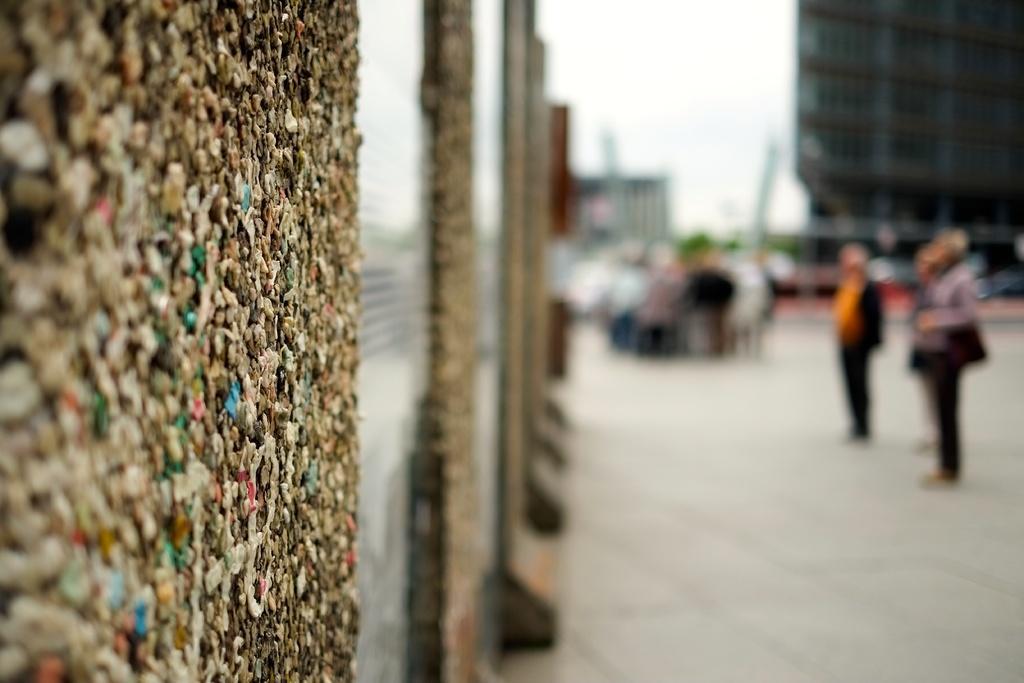In one or two sentences, can you explain what this image depicts? In this image we can see a wall. We can also see a group of people on the ground, a building and the sky. 